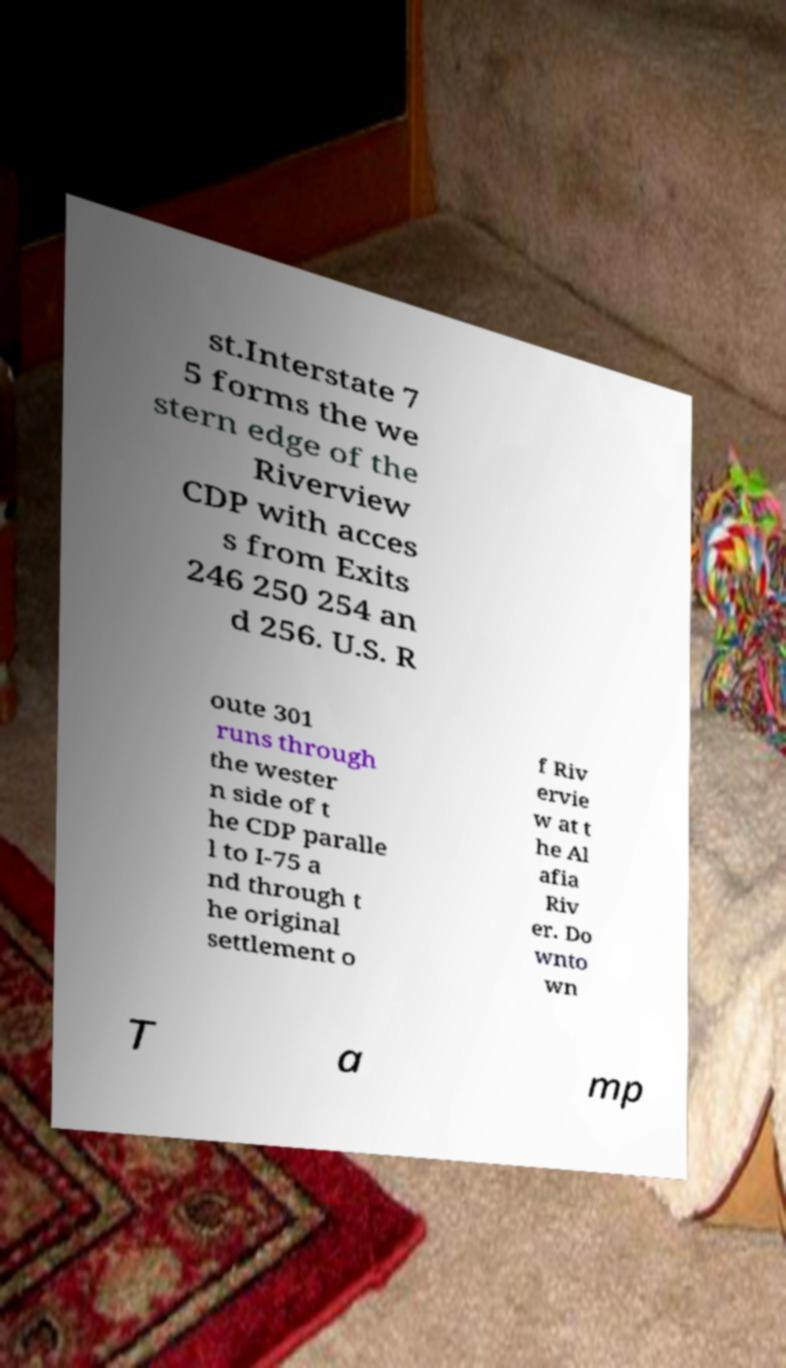Could you assist in decoding the text presented in this image and type it out clearly? st.Interstate 7 5 forms the we stern edge of the Riverview CDP with acces s from Exits 246 250 254 an d 256. U.S. R oute 301 runs through the wester n side of t he CDP paralle l to I-75 a nd through t he original settlement o f Riv ervie w at t he Al afia Riv er. Do wnto wn T a mp 